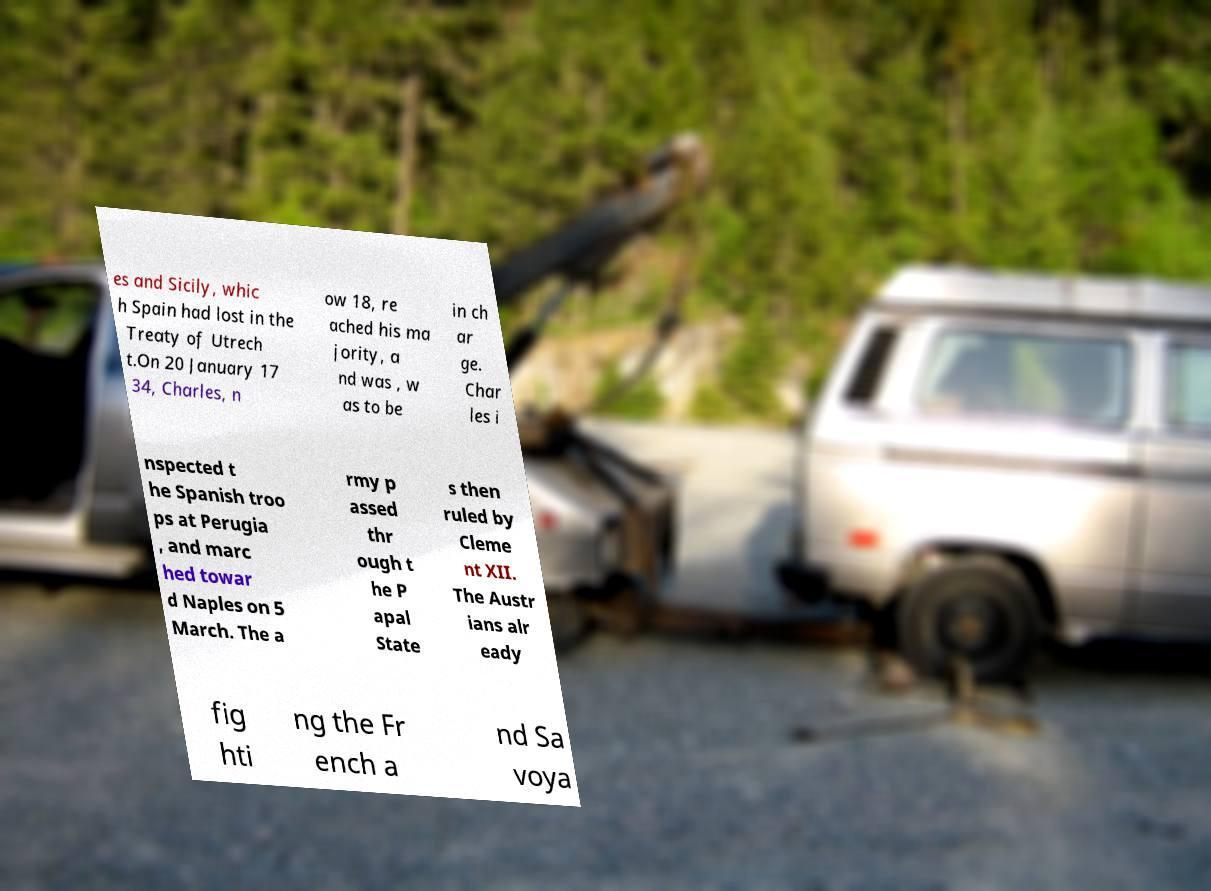What messages or text are displayed in this image? I need them in a readable, typed format. es and Sicily, whic h Spain had lost in the Treaty of Utrech t.On 20 January 17 34, Charles, n ow 18, re ached his ma jority, a nd was , w as to be in ch ar ge. Char les i nspected t he Spanish troo ps at Perugia , and marc hed towar d Naples on 5 March. The a rmy p assed thr ough t he P apal State s then ruled by Cleme nt XII. The Austr ians alr eady fig hti ng the Fr ench a nd Sa voya 